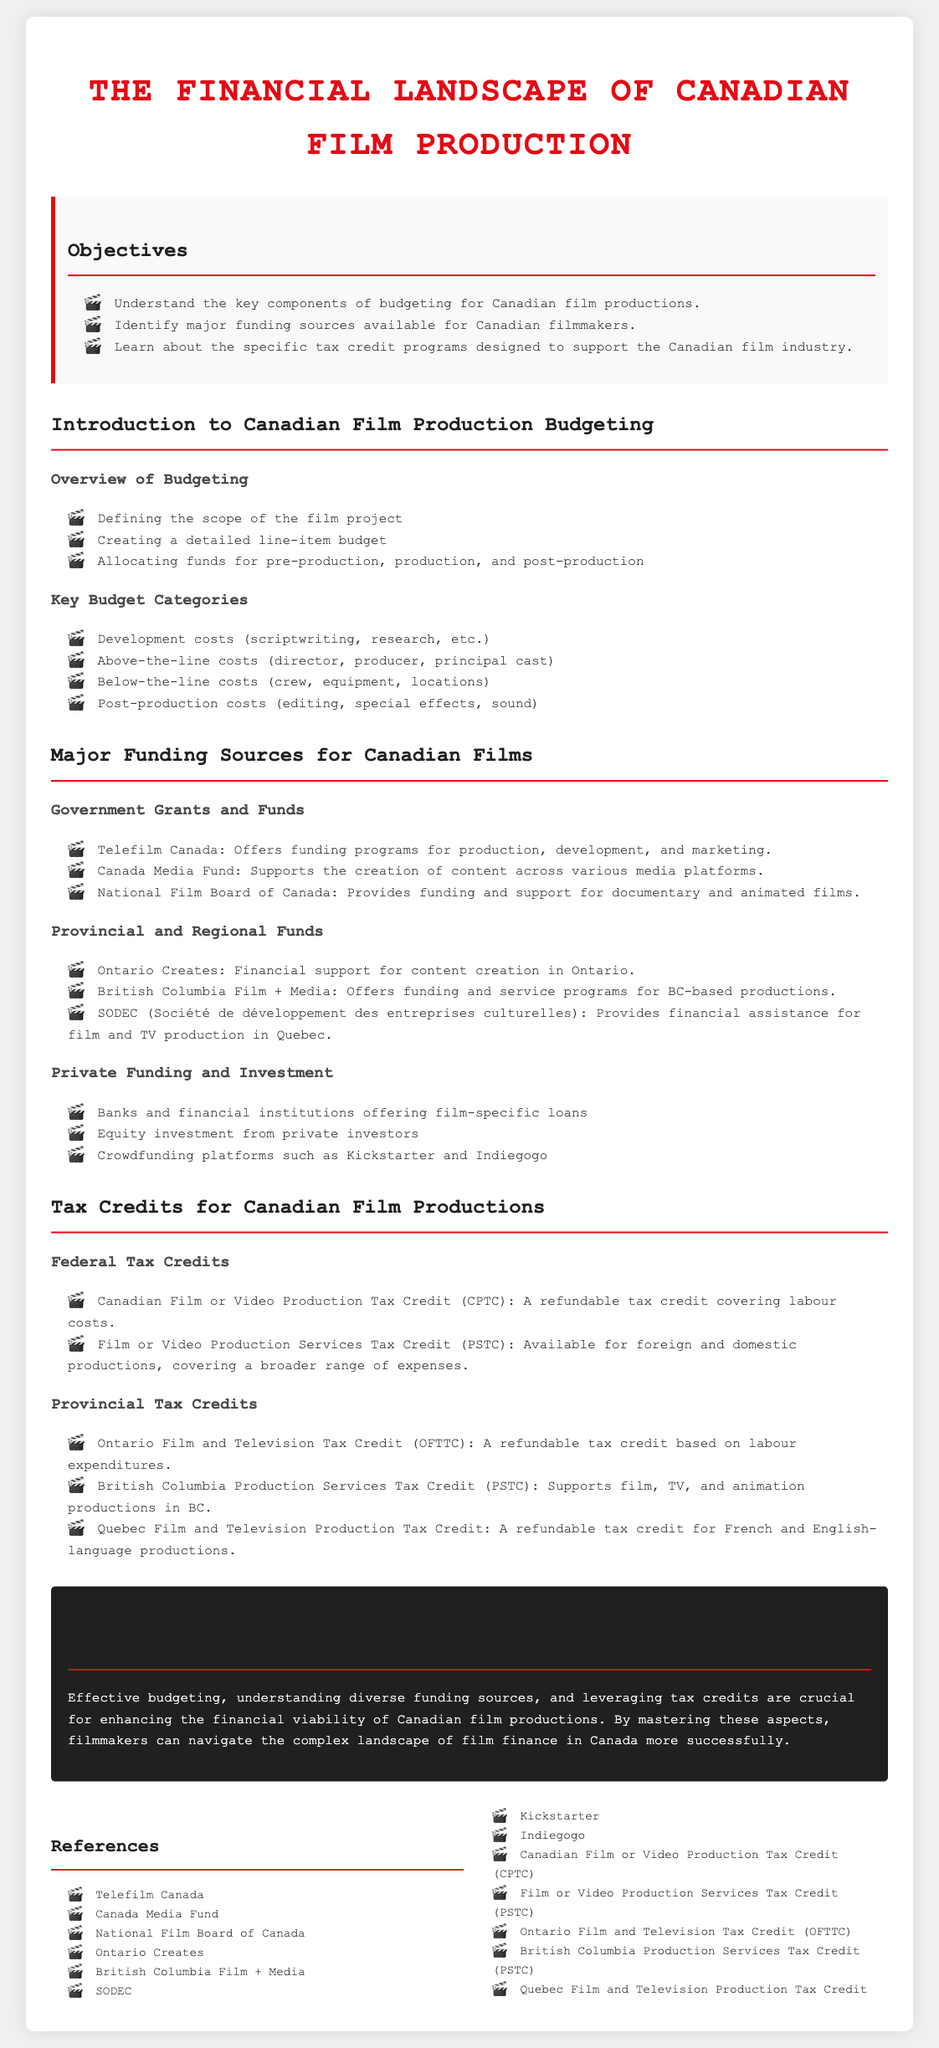what are the key components of budgeting for Canadian film productions? The key components of budgeting include understanding the scope of the project, creating a detailed line-item budget, and allocating funds for different production phases.
Answer: scope, detailed line-item budget, allocation of funds which organization offers funding programs for production in Canada? Telefilm Canada is mentioned as providing funding programs for production, development, and marketing.
Answer: Telefilm Canada what is the refundable tax credit covering labour costs called? The Canadian Film or Video Production Tax Credit (CPTC) is a refundable tax credit covering labour costs.
Answer: CPTC name a crowdfunding platform mentioned in the document. The document mentions Kickstarter and Indiegogo as crowdfunding platforms.
Answer: Kickstarter which provincial funding supports content creation in Ontario? Ontario Creates is the provincial funding that supports content creation in Ontario.
Answer: Ontario Creates how many major funding sources are identified for Canadian films? There are three major funding sources identified: government grants and funds, provincial and regional funds, and private funding.
Answer: three what are below-the-line costs associated with? Below-the-line costs are associated with crew, equipment, and locations used in film production.
Answer: crew, equipment, locations list one type of federal tax credit for film productions. The Film or Video Production Services Tax Credit (PSTC) is one type of federal tax credit available.
Answer: PSTC what is the role of the National Film Board of Canada? The National Film Board of Canada provides funding and support specifically for documentary and animated films.
Answer: funding and support for documentary and animated films 